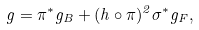<formula> <loc_0><loc_0><loc_500><loc_500>g = \pi ^ { * } g _ { B } + ( h \circ \pi ) ^ { 2 } \sigma ^ { * } g _ { F } ,</formula> 